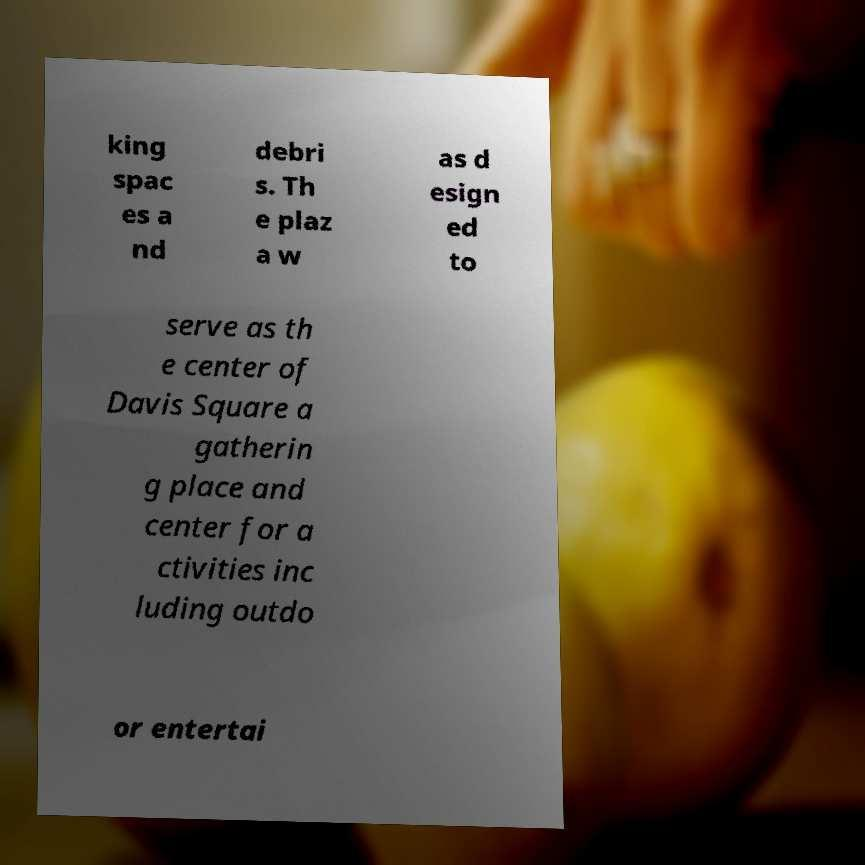I need the written content from this picture converted into text. Can you do that? king spac es a nd debri s. Th e plaz a w as d esign ed to serve as th e center of Davis Square a gatherin g place and center for a ctivities inc luding outdo or entertai 